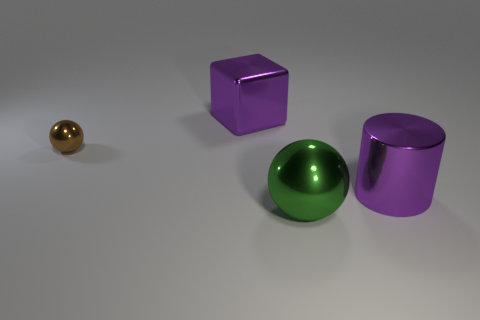Add 3 small yellow metallic spheres. How many objects exist? 7 Add 1 brown metal spheres. How many brown metal spheres are left? 2 Add 4 big green metallic balls. How many big green metallic balls exist? 5 Subtract 0 yellow spheres. How many objects are left? 4 Subtract all cylinders. How many objects are left? 3 Subtract all yellow cylinders. Subtract all red cubes. How many cylinders are left? 1 Subtract all green blocks. How many brown balls are left? 1 Subtract all small shiny balls. Subtract all big objects. How many objects are left? 0 